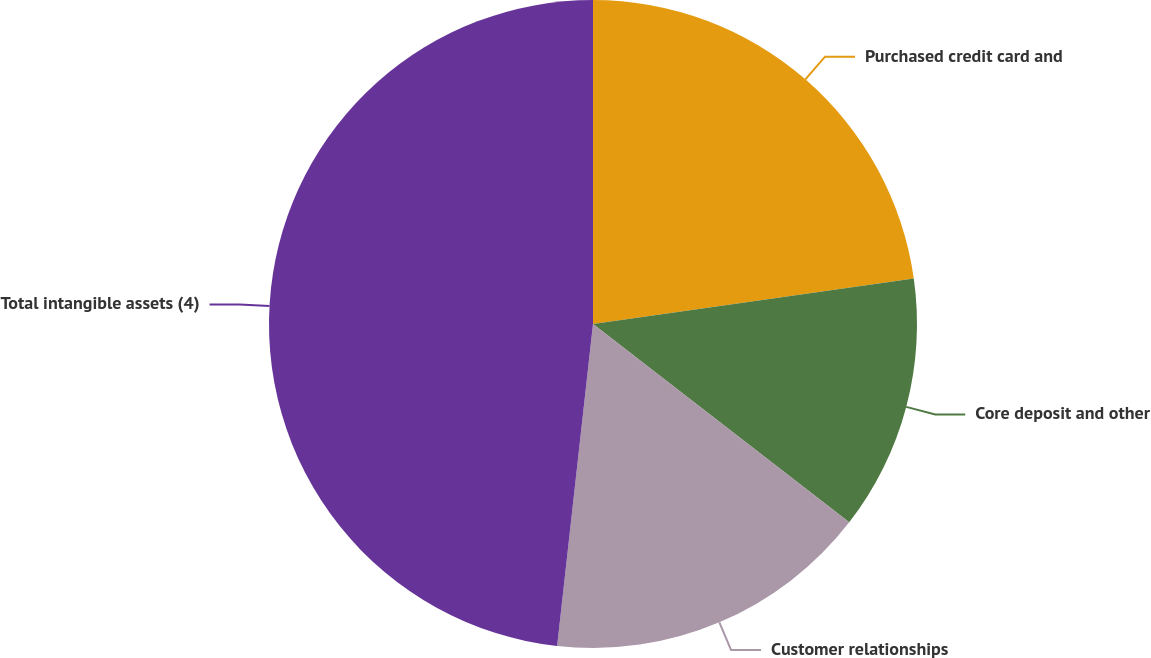<chart> <loc_0><loc_0><loc_500><loc_500><pie_chart><fcel>Purchased credit card and<fcel>Core deposit and other<fcel>Customer relationships<fcel>Total intangible assets (4)<nl><fcel>22.75%<fcel>12.73%<fcel>16.28%<fcel>48.23%<nl></chart> 